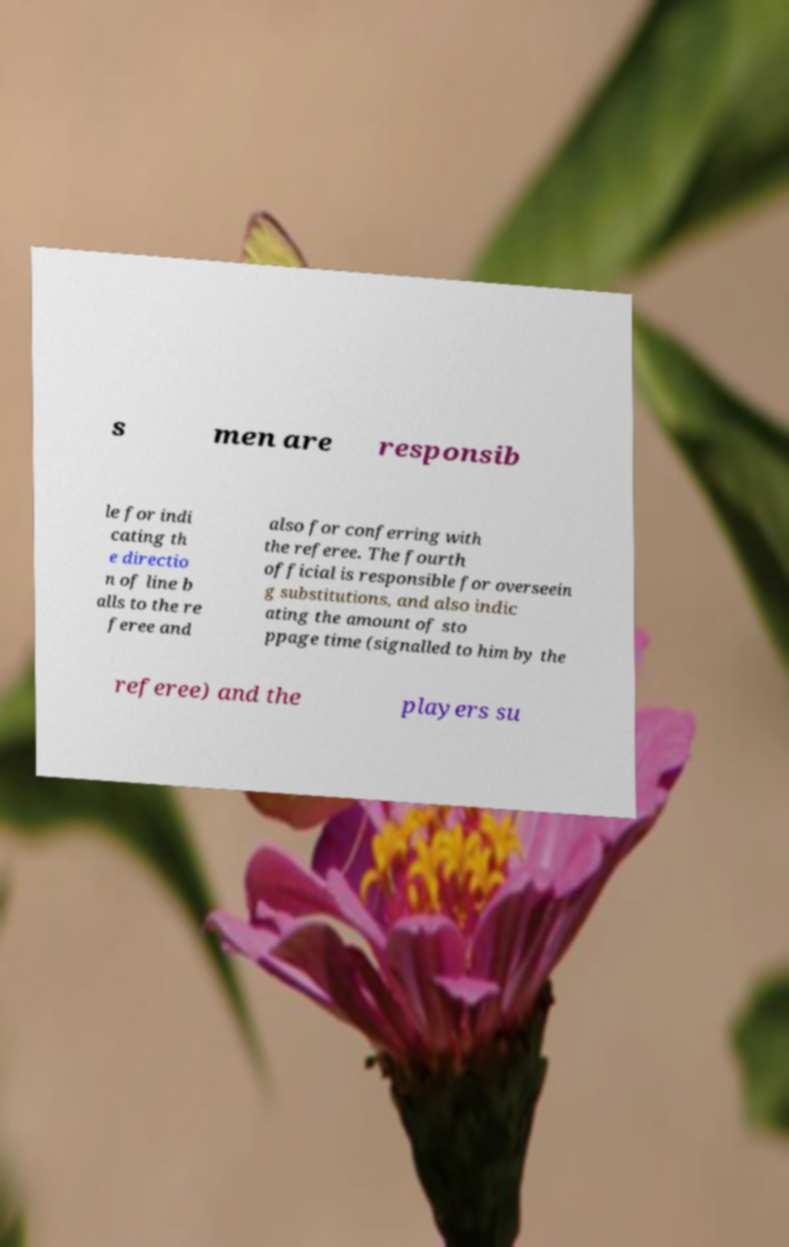Can you read and provide the text displayed in the image?This photo seems to have some interesting text. Can you extract and type it out for me? s men are responsib le for indi cating th e directio n of line b alls to the re feree and also for conferring with the referee. The fourth official is responsible for overseein g substitutions, and also indic ating the amount of sto ppage time (signalled to him by the referee) and the players su 